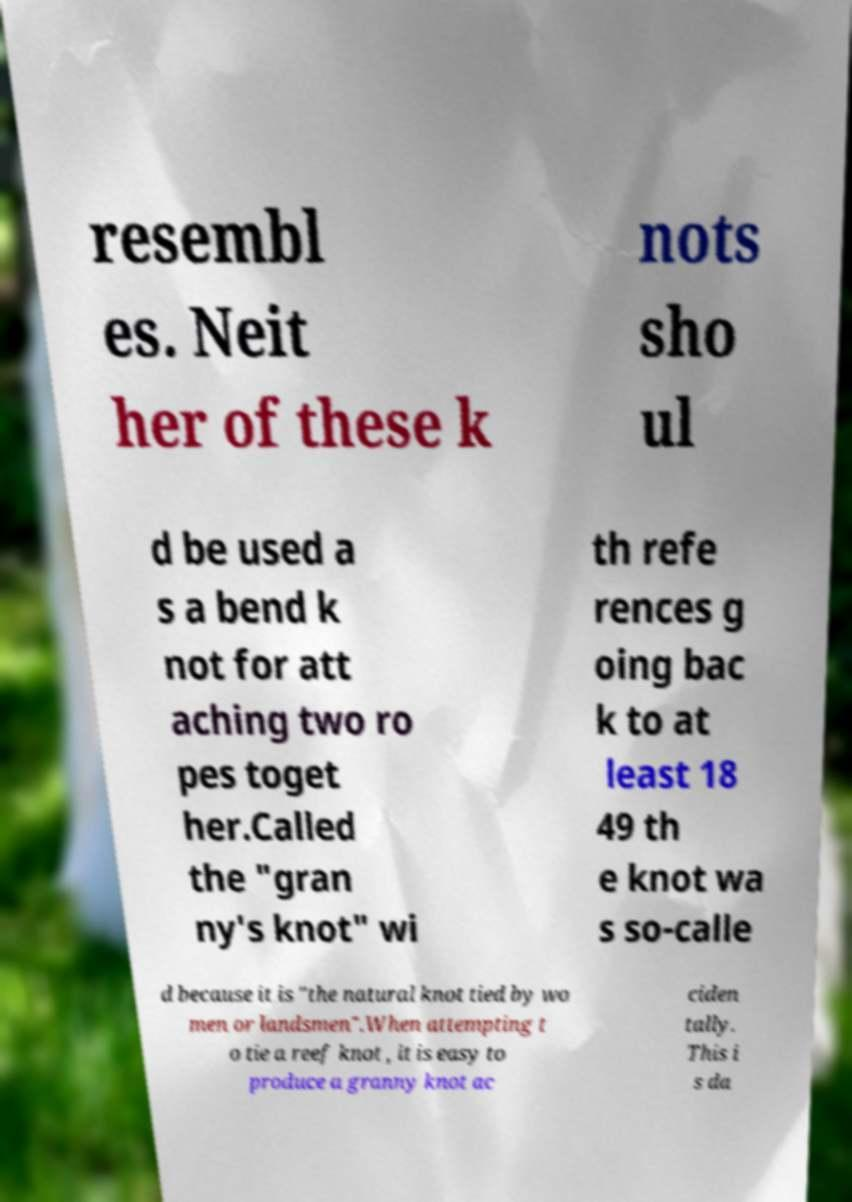Please identify and transcribe the text found in this image. resembl es. Neit her of these k nots sho ul d be used a s a bend k not for att aching two ro pes toget her.Called the "gran ny's knot" wi th refe rences g oing bac k to at least 18 49 th e knot wa s so-calle d because it is "the natural knot tied by wo men or landsmen".When attempting t o tie a reef knot , it is easy to produce a granny knot ac ciden tally. This i s da 